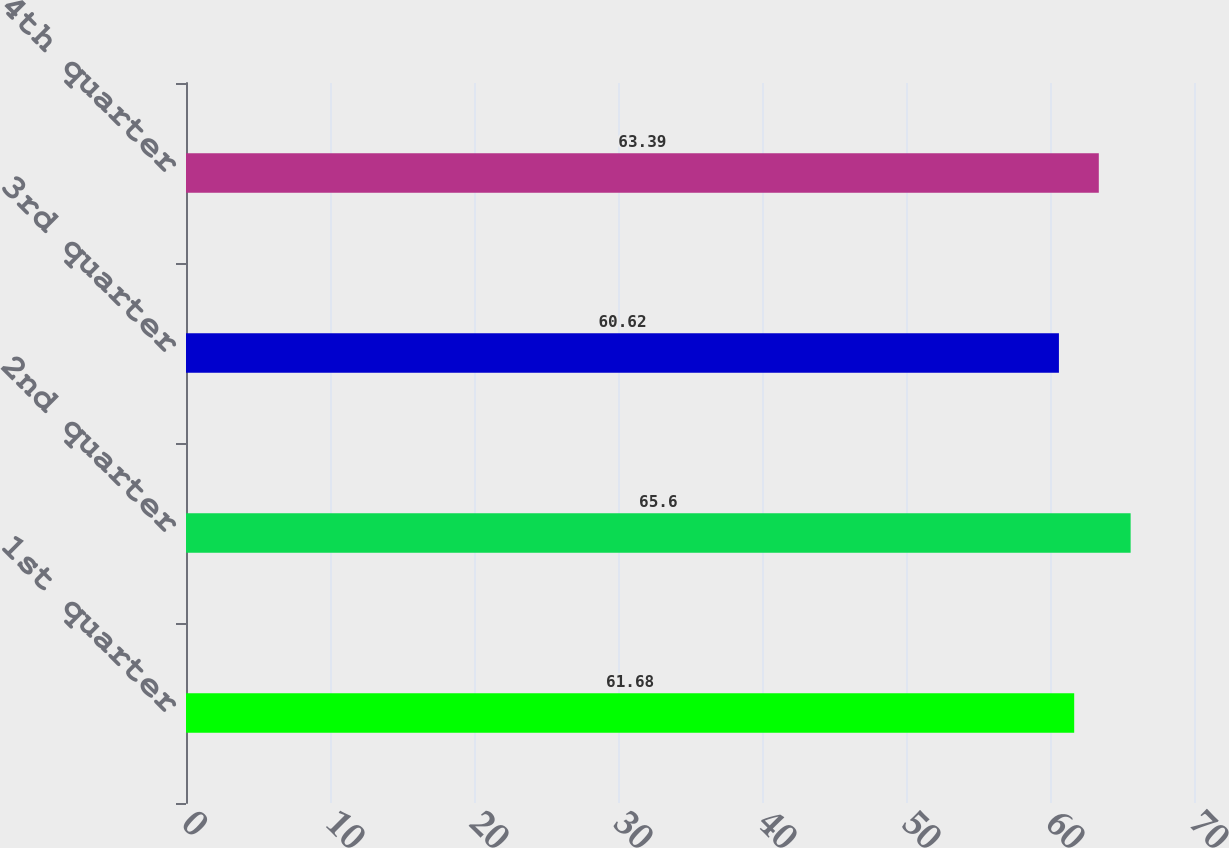<chart> <loc_0><loc_0><loc_500><loc_500><bar_chart><fcel>1st quarter<fcel>2nd quarter<fcel>3rd quarter<fcel>4th quarter<nl><fcel>61.68<fcel>65.6<fcel>60.62<fcel>63.39<nl></chart> 